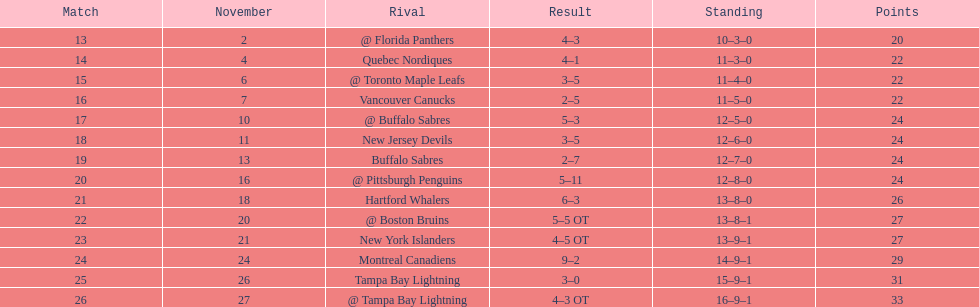What was the total penalty minutes that dave brown had on the 1993-1994 flyers? 137. 